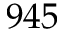Convert formula to latex. <formula><loc_0><loc_0><loc_500><loc_500>9 4 5</formula> 